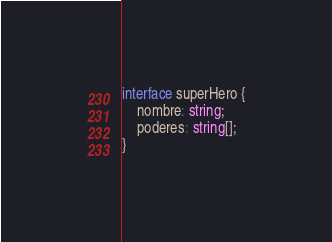Convert code to text. <code><loc_0><loc_0><loc_500><loc_500><_TypeScript_>interface superHero {
    nombre: string;
    poderes: string[];
}</code> 